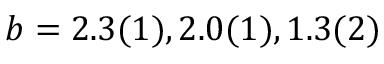<formula> <loc_0><loc_0><loc_500><loc_500>b = 2 . 3 ( 1 ) , 2 . 0 ( 1 ) , 1 . 3 ( 2 )</formula> 